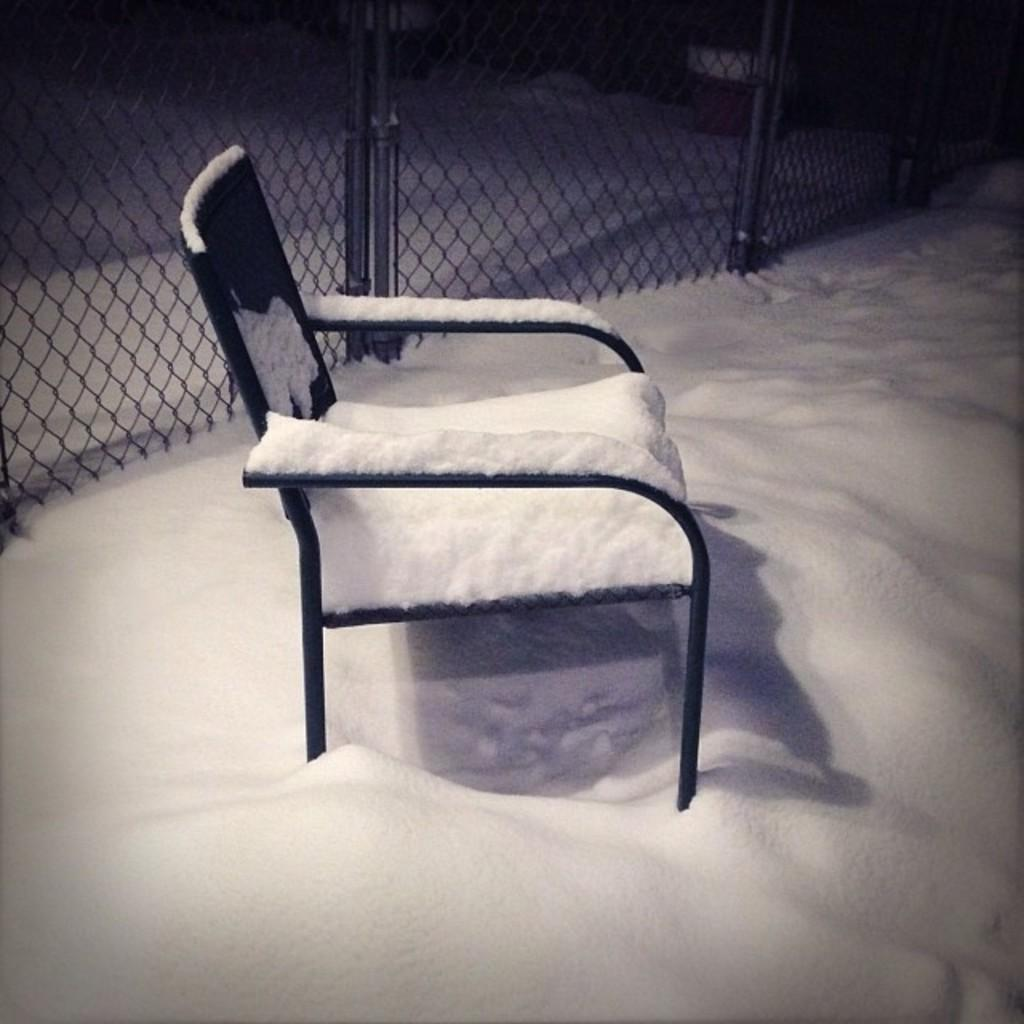What is the primary feature of the landscape in the image? There is snow in the image. What object is located in the middle of the image? There is a chair in the middle of the image. What can be seen in the background of the image? There is fencing visible in the background of the image. What type of throne is being used by the king in the image? There is no king or throne present in the image; it features snow, a chair, and fencing. 